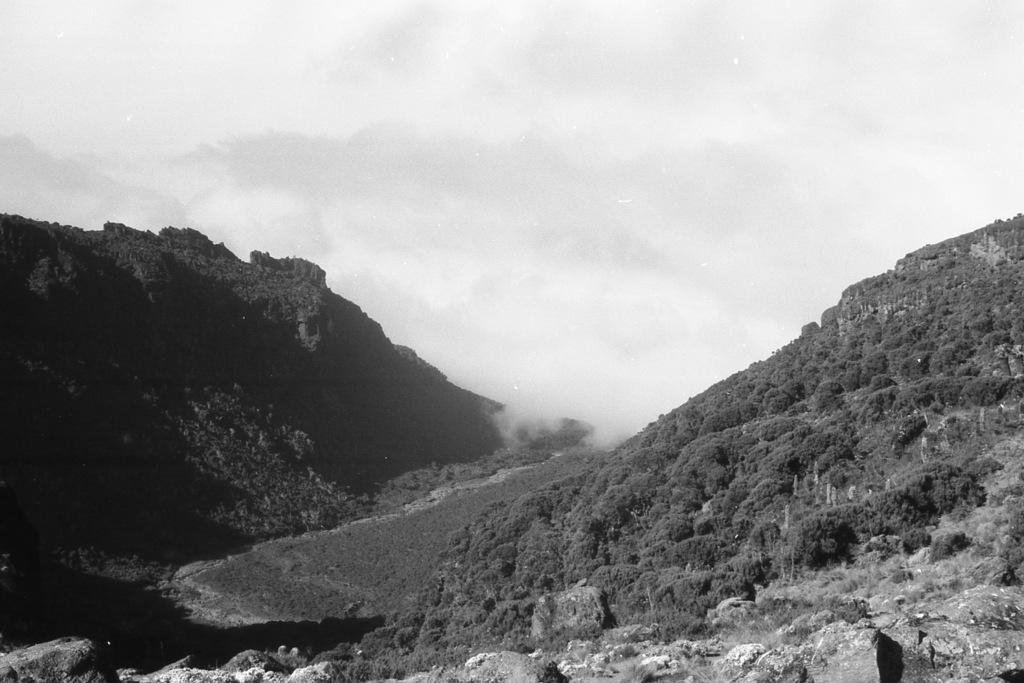What type of natural landscape is depicted in the image? The image features mountains, trees, and rocks. Can you describe the weather conditions in the image? The presence of smoke suggests that there may be a fire or some form of activity causing smoke in the area. What is visible in the background of the image? The sky is visible in the background of the image. How many boys are sitting on the rocks in the image? There are no boys present in the image; it features mountains, trees, rocks, smoke, and the sky. 